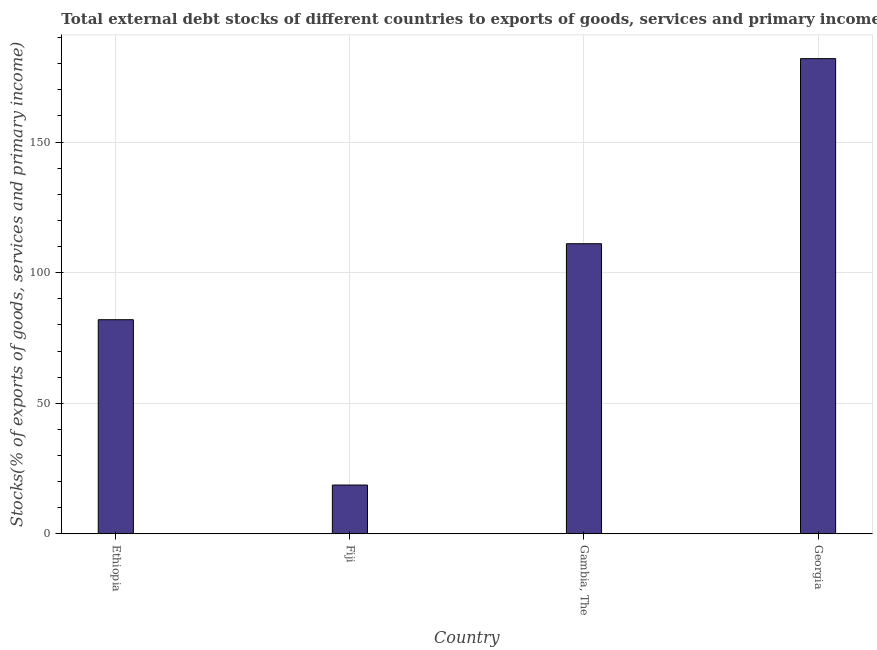Does the graph contain any zero values?
Provide a succinct answer. No. What is the title of the graph?
Give a very brief answer. Total external debt stocks of different countries to exports of goods, services and primary income in 2008. What is the label or title of the Y-axis?
Your answer should be compact. Stocks(% of exports of goods, services and primary income). What is the external debt stocks in Fiji?
Provide a succinct answer. 18.69. Across all countries, what is the maximum external debt stocks?
Provide a short and direct response. 181.93. Across all countries, what is the minimum external debt stocks?
Keep it short and to the point. 18.69. In which country was the external debt stocks maximum?
Offer a very short reply. Georgia. In which country was the external debt stocks minimum?
Your answer should be compact. Fiji. What is the sum of the external debt stocks?
Provide a short and direct response. 393.67. What is the difference between the external debt stocks in Ethiopia and Georgia?
Keep it short and to the point. -99.95. What is the average external debt stocks per country?
Your answer should be compact. 98.42. What is the median external debt stocks?
Give a very brief answer. 96.52. In how many countries, is the external debt stocks greater than 150 %?
Your answer should be compact. 1. What is the ratio of the external debt stocks in Ethiopia to that in Georgia?
Provide a succinct answer. 0.45. Is the external debt stocks in Ethiopia less than that in Gambia, The?
Provide a short and direct response. Yes. What is the difference between the highest and the second highest external debt stocks?
Offer a very short reply. 70.86. Is the sum of the external debt stocks in Ethiopia and Fiji greater than the maximum external debt stocks across all countries?
Your answer should be compact. No. What is the difference between the highest and the lowest external debt stocks?
Your answer should be very brief. 163.24. Are all the bars in the graph horizontal?
Your answer should be very brief. No. What is the Stocks(% of exports of goods, services and primary income) in Ethiopia?
Provide a succinct answer. 81.98. What is the Stocks(% of exports of goods, services and primary income) in Fiji?
Offer a very short reply. 18.69. What is the Stocks(% of exports of goods, services and primary income) in Gambia, The?
Provide a short and direct response. 111.07. What is the Stocks(% of exports of goods, services and primary income) of Georgia?
Give a very brief answer. 181.93. What is the difference between the Stocks(% of exports of goods, services and primary income) in Ethiopia and Fiji?
Give a very brief answer. 63.29. What is the difference between the Stocks(% of exports of goods, services and primary income) in Ethiopia and Gambia, The?
Keep it short and to the point. -29.09. What is the difference between the Stocks(% of exports of goods, services and primary income) in Ethiopia and Georgia?
Ensure brevity in your answer.  -99.95. What is the difference between the Stocks(% of exports of goods, services and primary income) in Fiji and Gambia, The?
Give a very brief answer. -92.38. What is the difference between the Stocks(% of exports of goods, services and primary income) in Fiji and Georgia?
Your answer should be very brief. -163.24. What is the difference between the Stocks(% of exports of goods, services and primary income) in Gambia, The and Georgia?
Your answer should be very brief. -70.86. What is the ratio of the Stocks(% of exports of goods, services and primary income) in Ethiopia to that in Fiji?
Make the answer very short. 4.39. What is the ratio of the Stocks(% of exports of goods, services and primary income) in Ethiopia to that in Gambia, The?
Your response must be concise. 0.74. What is the ratio of the Stocks(% of exports of goods, services and primary income) in Ethiopia to that in Georgia?
Offer a terse response. 0.45. What is the ratio of the Stocks(% of exports of goods, services and primary income) in Fiji to that in Gambia, The?
Ensure brevity in your answer.  0.17. What is the ratio of the Stocks(% of exports of goods, services and primary income) in Fiji to that in Georgia?
Your response must be concise. 0.1. What is the ratio of the Stocks(% of exports of goods, services and primary income) in Gambia, The to that in Georgia?
Make the answer very short. 0.61. 